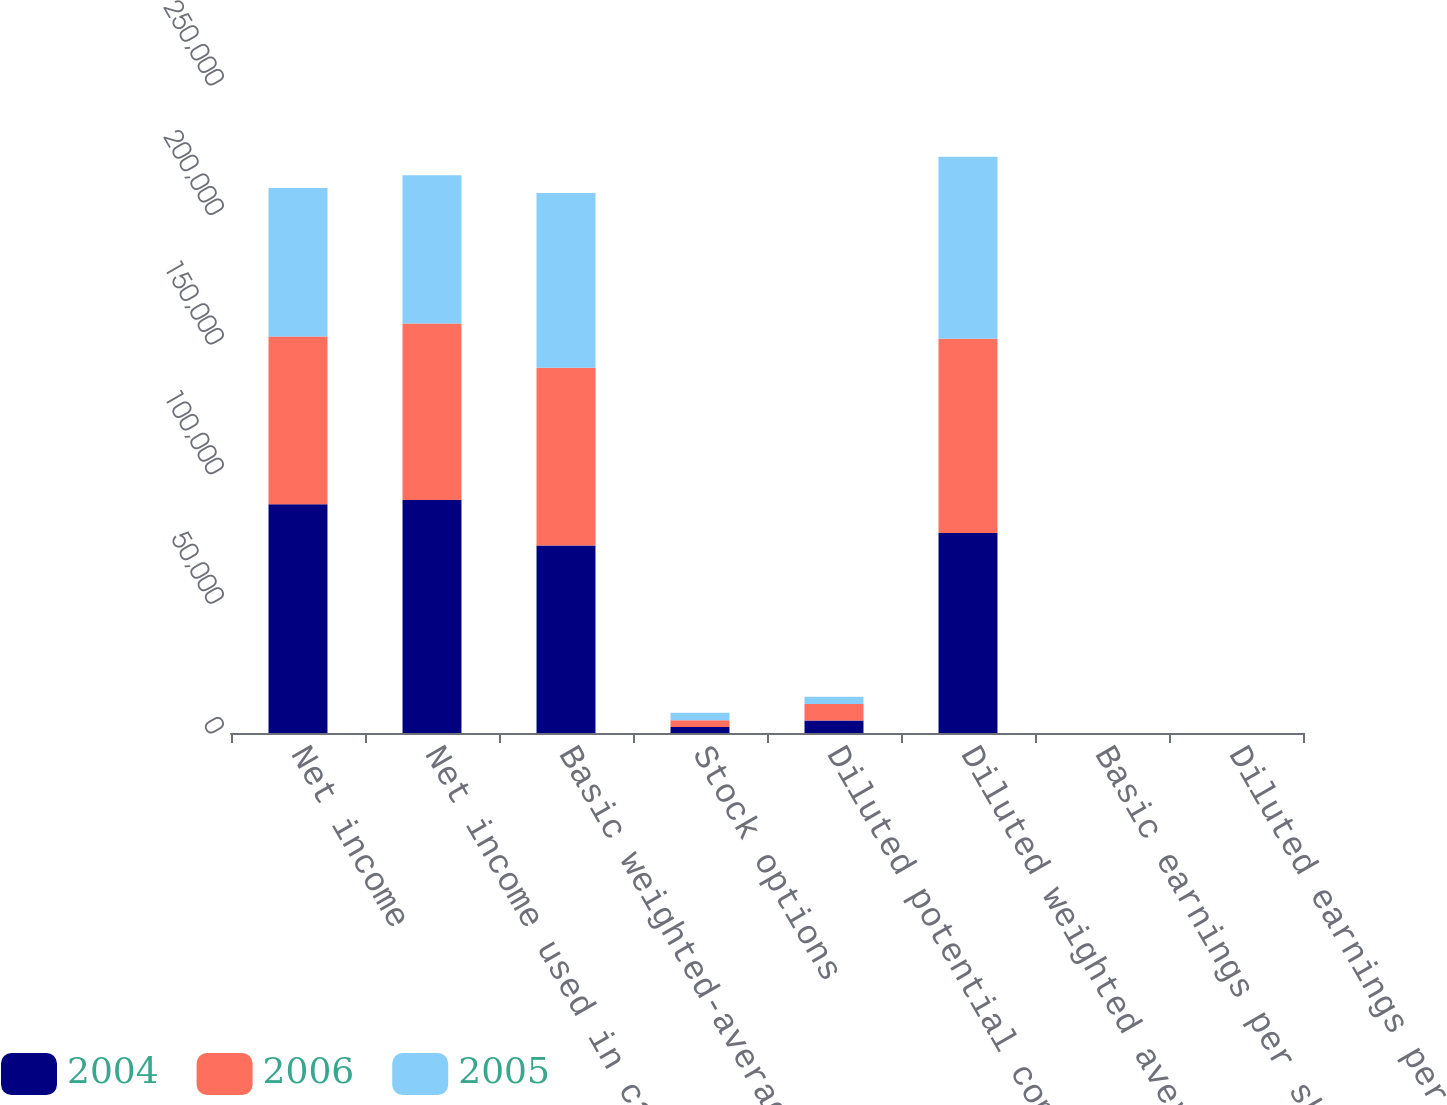Convert chart to OTSL. <chart><loc_0><loc_0><loc_500><loc_500><stacked_bar_chart><ecel><fcel>Net income<fcel>Net income used in calculating<fcel>Basic weighted-average common<fcel>Stock options<fcel>Diluted potential common<fcel>Diluted weighted average<fcel>Basic earnings per share<fcel>Diluted earnings per share^(1)<nl><fcel>2004<fcel>88211<fcel>89871<fcel>72307<fcel>2346<fcel>4855<fcel>77162<fcel>1.22<fcel>1.16<nl><fcel>2006<fcel>64785<fcel>68070<fcel>68643<fcel>2561<fcel>6299<fcel>74942<fcel>0.94<fcel>0.91<nl><fcel>2005<fcel>57284<fcel>57284<fcel>67389<fcel>2862<fcel>2862<fcel>70251<fcel>0.85<fcel>0.82<nl></chart> 